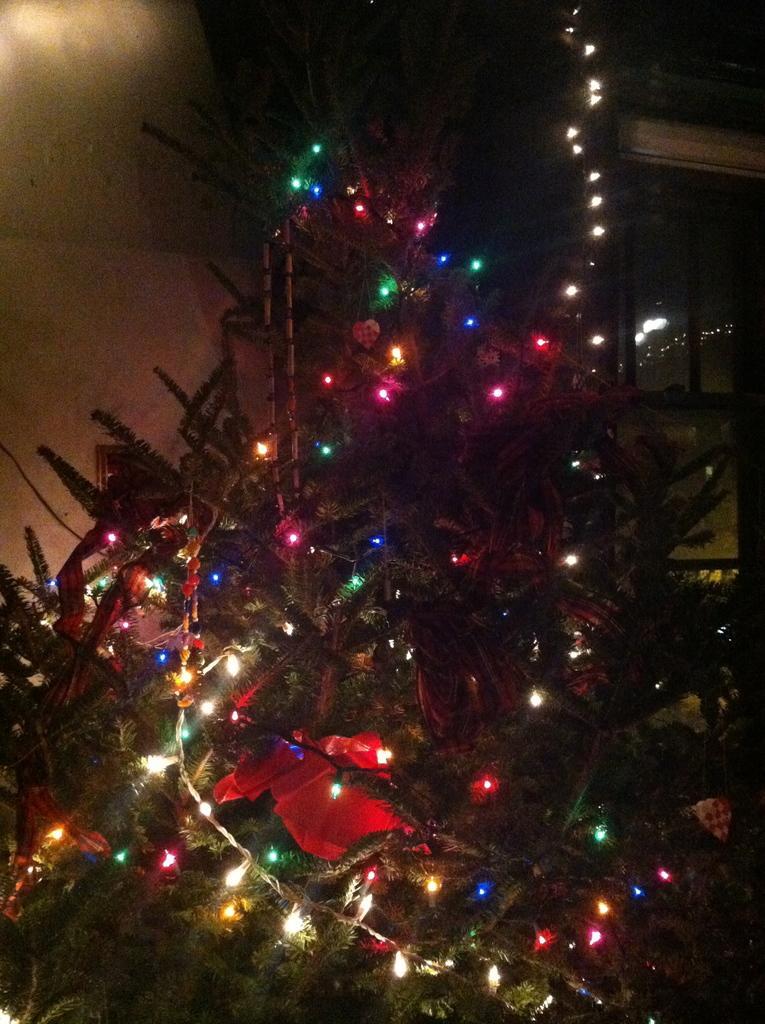Could you give a brief overview of what you see in this image? In this image there is a tree decorated with rope lights and some decorative items, and in the background there is wall. 